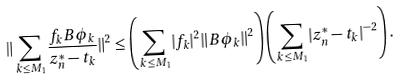Convert formula to latex. <formula><loc_0><loc_0><loc_500><loc_500>\| \sum _ { k \leq M _ { 1 } } \frac { f _ { k } B \phi _ { k } } { z ^ { * } _ { n } - t _ { k } } \| ^ { 2 } \leq \left ( \sum _ { k \leq M _ { 1 } } | f _ { k } | ^ { 2 } \| B \phi _ { k } \| ^ { 2 } \right ) \left ( \sum _ { k \leq M _ { 1 } } | z ^ { * } _ { n } - t _ { k } | ^ { - 2 } \right ) .</formula> 